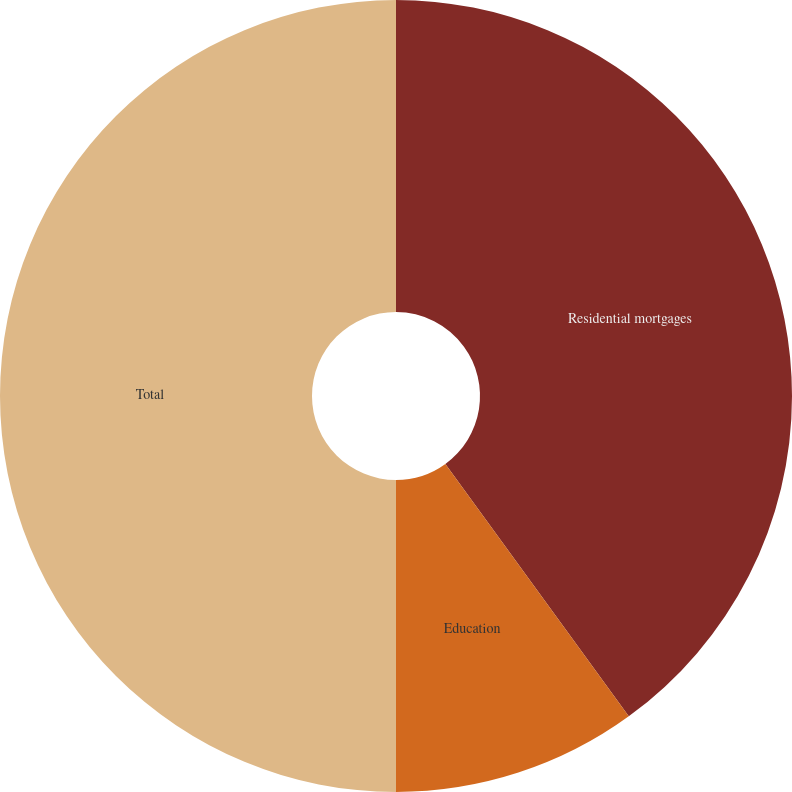Convert chart. <chart><loc_0><loc_0><loc_500><loc_500><pie_chart><fcel>Residential mortgages<fcel>Education<fcel>Total<nl><fcel>40.0%<fcel>10.0%<fcel>50.0%<nl></chart> 